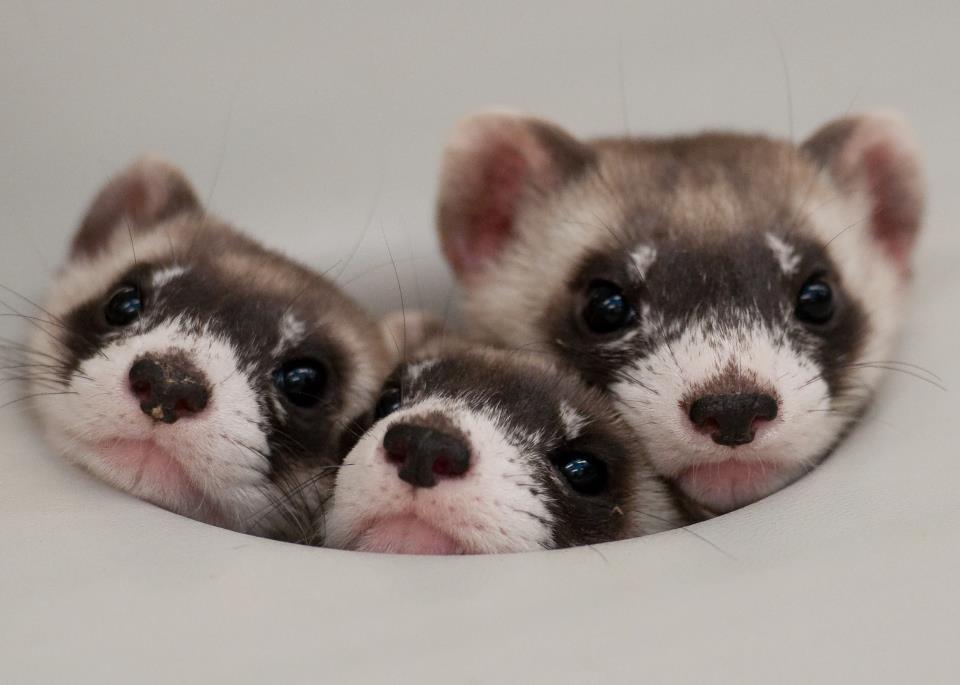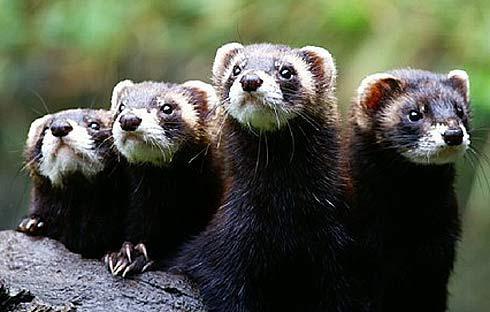The first image is the image on the left, the second image is the image on the right. Assess this claim about the two images: "Each image contains one ferret standing on dirt ground, with at least one front and one back paw on the ground.". Correct or not? Answer yes or no. No. The first image is the image on the left, the second image is the image on the right. Given the left and right images, does the statement "Both animals are standing on all fours on the ground." hold true? Answer yes or no. No. 